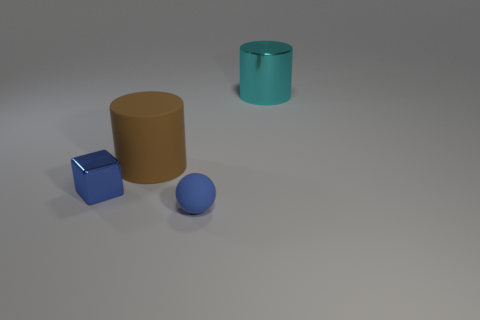There is a small thing that is the same color as the small metallic cube; what shape is it?
Ensure brevity in your answer.  Sphere. Do the brown object and the metallic thing that is to the right of the large brown object have the same shape?
Offer a terse response. Yes. What is the thing in front of the shiny object in front of the large cyan object that is behind the small blue matte thing made of?
Make the answer very short. Rubber. How many other objects are the same size as the blue matte ball?
Provide a short and direct response. 1. Is the color of the big metallic object the same as the large rubber thing?
Ensure brevity in your answer.  No. There is a cylinder in front of the big thing behind the big brown rubber cylinder; how many small blue metal objects are left of it?
Offer a very short reply. 1. What is the material of the blue thing that is behind the object in front of the tiny blue shiny thing?
Your answer should be very brief. Metal. Are there any small blue metal objects of the same shape as the large cyan metal object?
Your response must be concise. No. The matte object that is the same size as the blue metal cube is what color?
Provide a short and direct response. Blue. How many objects are matte objects behind the small metal block or things that are right of the big brown thing?
Give a very brief answer. 3. 